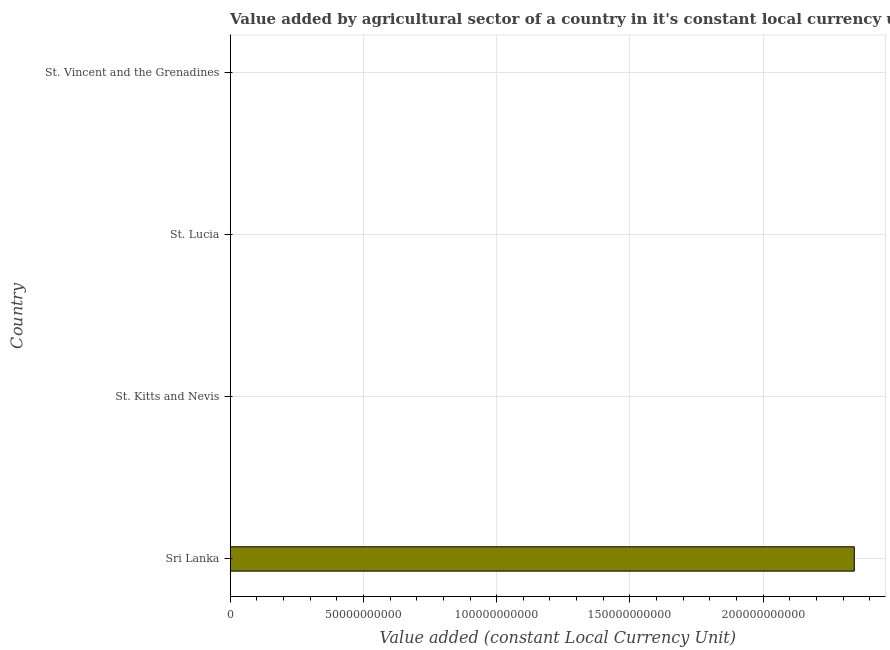Does the graph contain any zero values?
Give a very brief answer. No. Does the graph contain grids?
Your response must be concise. Yes. What is the title of the graph?
Your answer should be compact. Value added by agricultural sector of a country in it's constant local currency unit. What is the label or title of the X-axis?
Provide a short and direct response. Value added (constant Local Currency Unit). What is the value added by agriculture sector in St. Kitts and Nevis?
Give a very brief answer. 2.59e+07. Across all countries, what is the maximum value added by agriculture sector?
Make the answer very short. 2.34e+11. Across all countries, what is the minimum value added by agriculture sector?
Your response must be concise. 2.59e+07. In which country was the value added by agriculture sector maximum?
Offer a very short reply. Sri Lanka. In which country was the value added by agriculture sector minimum?
Provide a succinct answer. St. Kitts and Nevis. What is the sum of the value added by agriculture sector?
Keep it short and to the point. 2.34e+11. What is the difference between the value added by agriculture sector in St. Kitts and Nevis and St. Lucia?
Ensure brevity in your answer.  -9.56e+07. What is the average value added by agriculture sector per country?
Make the answer very short. 5.86e+1. What is the median value added by agriculture sector?
Give a very brief answer. 9.43e+07. In how many countries, is the value added by agriculture sector greater than 40000000000 LCU?
Your answer should be compact. 1. What is the ratio of the value added by agriculture sector in Sri Lanka to that in St. Kitts and Nevis?
Your answer should be compact. 9047.2. What is the difference between the highest and the second highest value added by agriculture sector?
Ensure brevity in your answer.  2.34e+11. Is the sum of the value added by agriculture sector in St. Kitts and Nevis and St. Vincent and the Grenadines greater than the maximum value added by agriculture sector across all countries?
Provide a short and direct response. No. What is the difference between the highest and the lowest value added by agriculture sector?
Give a very brief answer. 2.34e+11. How many bars are there?
Provide a short and direct response. 4. Are all the bars in the graph horizontal?
Keep it short and to the point. Yes. What is the difference between two consecutive major ticks on the X-axis?
Offer a very short reply. 5.00e+1. Are the values on the major ticks of X-axis written in scientific E-notation?
Provide a succinct answer. No. What is the Value added (constant Local Currency Unit) of Sri Lanka?
Offer a terse response. 2.34e+11. What is the Value added (constant Local Currency Unit) in St. Kitts and Nevis?
Ensure brevity in your answer.  2.59e+07. What is the Value added (constant Local Currency Unit) of St. Lucia?
Make the answer very short. 1.21e+08. What is the Value added (constant Local Currency Unit) in St. Vincent and the Grenadines?
Offer a very short reply. 6.71e+07. What is the difference between the Value added (constant Local Currency Unit) in Sri Lanka and St. Kitts and Nevis?
Your answer should be very brief. 2.34e+11. What is the difference between the Value added (constant Local Currency Unit) in Sri Lanka and St. Lucia?
Ensure brevity in your answer.  2.34e+11. What is the difference between the Value added (constant Local Currency Unit) in Sri Lanka and St. Vincent and the Grenadines?
Give a very brief answer. 2.34e+11. What is the difference between the Value added (constant Local Currency Unit) in St. Kitts and Nevis and St. Lucia?
Give a very brief answer. -9.56e+07. What is the difference between the Value added (constant Local Currency Unit) in St. Kitts and Nevis and St. Vincent and the Grenadines?
Ensure brevity in your answer.  -4.12e+07. What is the difference between the Value added (constant Local Currency Unit) in St. Lucia and St. Vincent and the Grenadines?
Your response must be concise. 5.43e+07. What is the ratio of the Value added (constant Local Currency Unit) in Sri Lanka to that in St. Kitts and Nevis?
Offer a very short reply. 9047.2. What is the ratio of the Value added (constant Local Currency Unit) in Sri Lanka to that in St. Lucia?
Offer a terse response. 1928.18. What is the ratio of the Value added (constant Local Currency Unit) in Sri Lanka to that in St. Vincent and the Grenadines?
Your answer should be very brief. 3489.55. What is the ratio of the Value added (constant Local Currency Unit) in St. Kitts and Nevis to that in St. Lucia?
Give a very brief answer. 0.21. What is the ratio of the Value added (constant Local Currency Unit) in St. Kitts and Nevis to that in St. Vincent and the Grenadines?
Provide a succinct answer. 0.39. What is the ratio of the Value added (constant Local Currency Unit) in St. Lucia to that in St. Vincent and the Grenadines?
Your answer should be very brief. 1.81. 